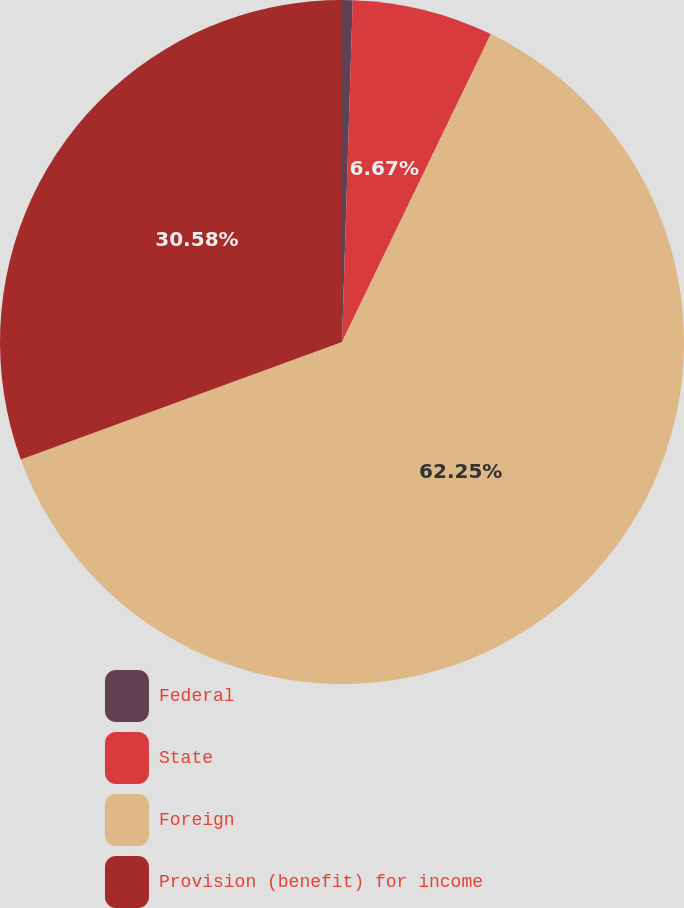Convert chart to OTSL. <chart><loc_0><loc_0><loc_500><loc_500><pie_chart><fcel>Federal<fcel>State<fcel>Foreign<fcel>Provision (benefit) for income<nl><fcel>0.5%<fcel>6.67%<fcel>62.25%<fcel>30.58%<nl></chart> 